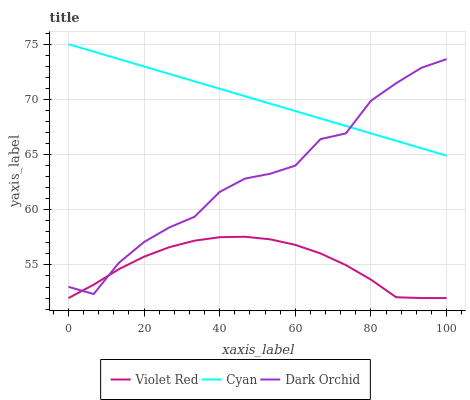Does Violet Red have the minimum area under the curve?
Answer yes or no. Yes. Does Cyan have the maximum area under the curve?
Answer yes or no. Yes. Does Dark Orchid have the minimum area under the curve?
Answer yes or no. No. Does Dark Orchid have the maximum area under the curve?
Answer yes or no. No. Is Cyan the smoothest?
Answer yes or no. Yes. Is Dark Orchid the roughest?
Answer yes or no. Yes. Is Violet Red the smoothest?
Answer yes or no. No. Is Violet Red the roughest?
Answer yes or no. No. Does Violet Red have the lowest value?
Answer yes or no. Yes. Does Dark Orchid have the lowest value?
Answer yes or no. No. Does Cyan have the highest value?
Answer yes or no. Yes. Does Dark Orchid have the highest value?
Answer yes or no. No. Is Violet Red less than Cyan?
Answer yes or no. Yes. Is Cyan greater than Violet Red?
Answer yes or no. Yes. Does Violet Red intersect Dark Orchid?
Answer yes or no. Yes. Is Violet Red less than Dark Orchid?
Answer yes or no. No. Is Violet Red greater than Dark Orchid?
Answer yes or no. No. Does Violet Red intersect Cyan?
Answer yes or no. No. 